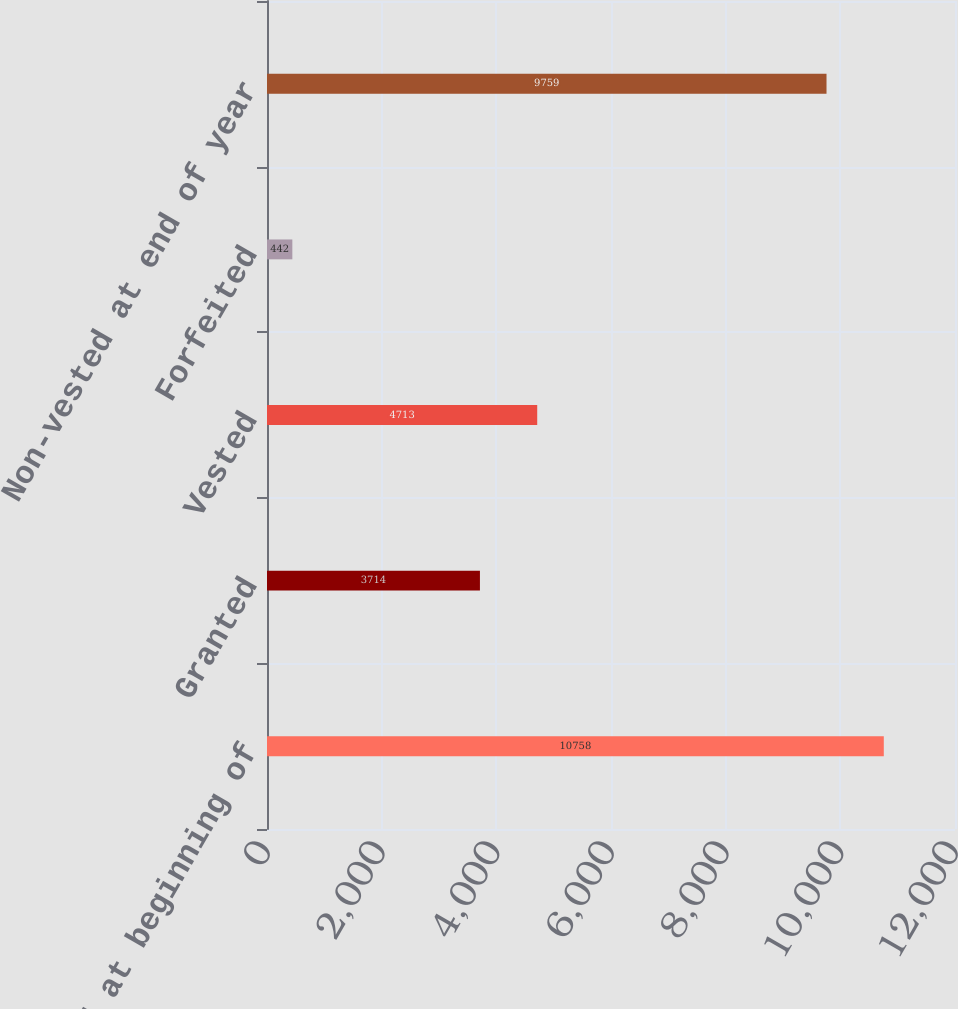Convert chart. <chart><loc_0><loc_0><loc_500><loc_500><bar_chart><fcel>Non-vested at beginning of<fcel>Granted<fcel>Vested<fcel>Forfeited<fcel>Non-vested at end of year<nl><fcel>10758<fcel>3714<fcel>4713<fcel>442<fcel>9759<nl></chart> 